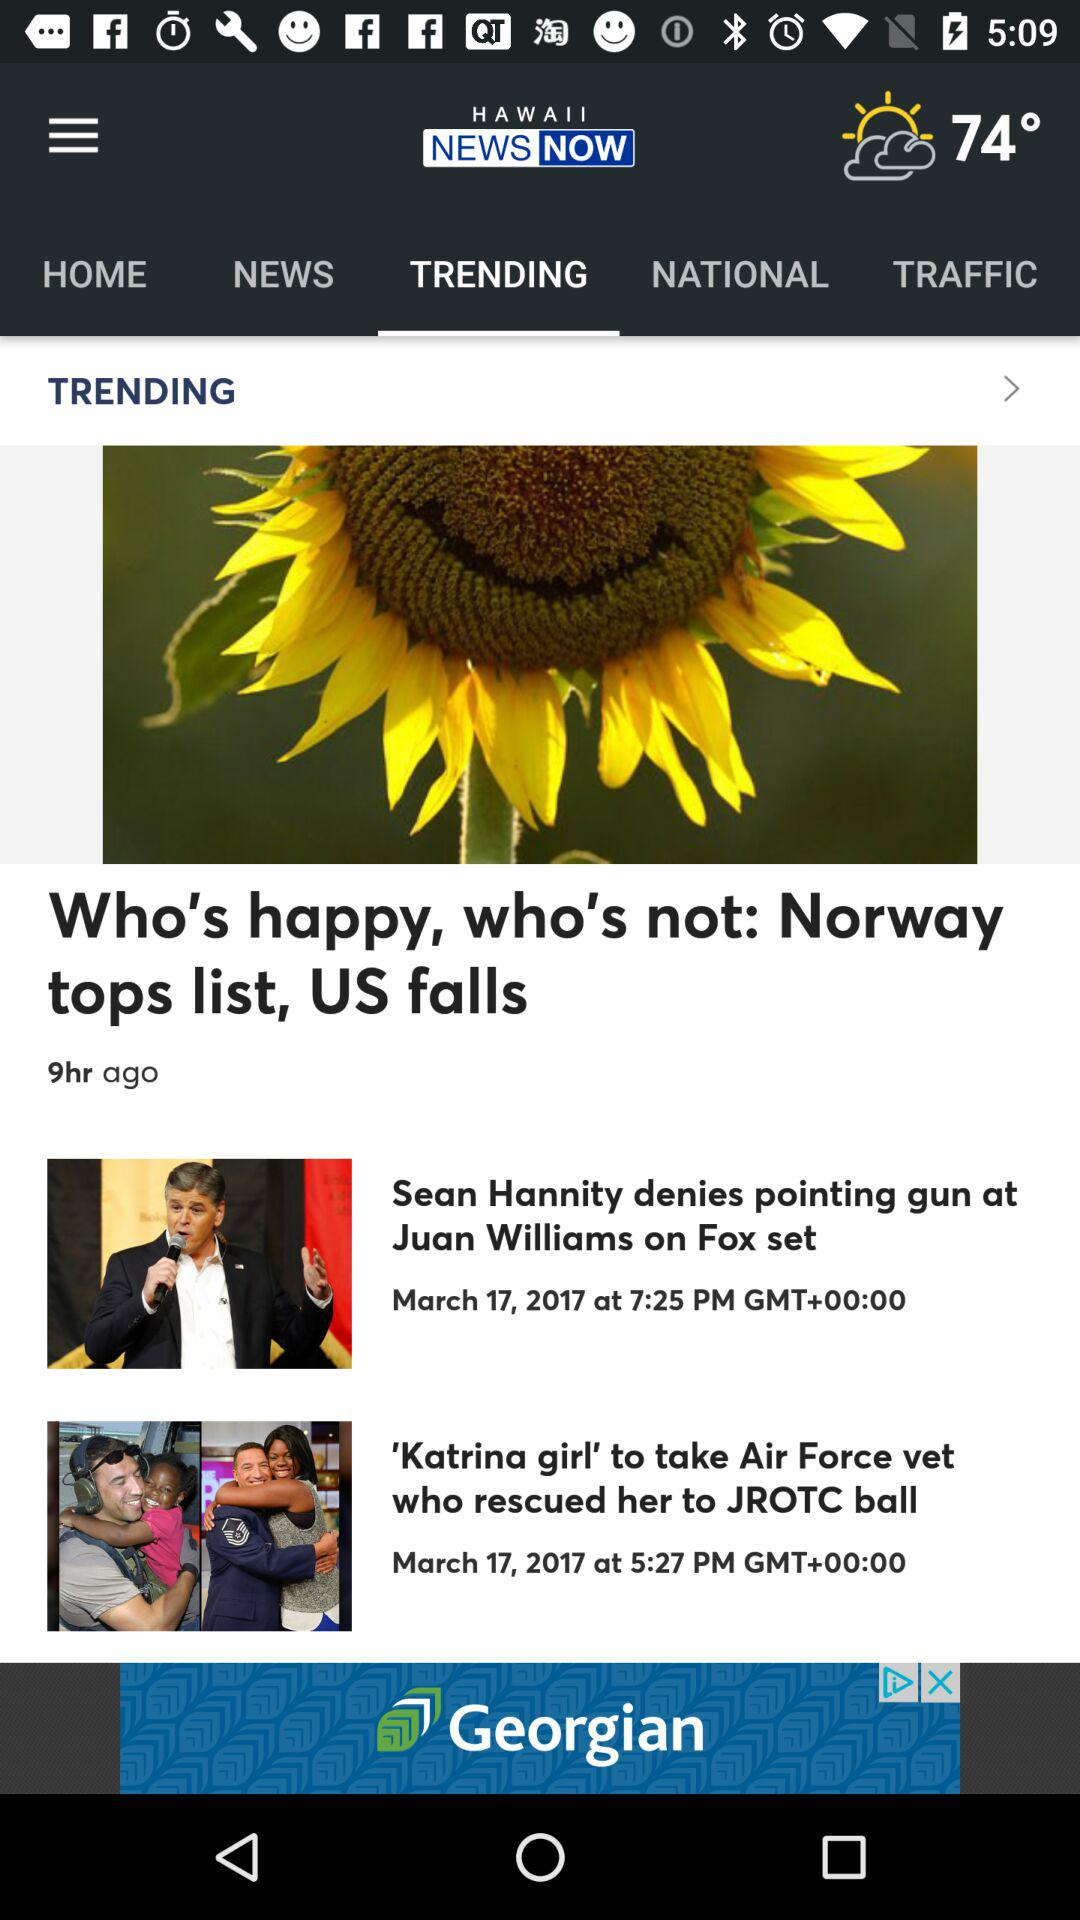Which tab is selected?
Answer the question using a single word or phrase. The selected tab is "TRENDING" 